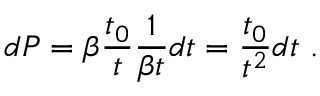Convert formula to latex. <formula><loc_0><loc_0><loc_500><loc_500>d P = \beta \frac { t _ { 0 } } { t } \frac { 1 } { \beta t } d t = \frac { t _ { 0 } } { t ^ { 2 } } d t \, .</formula> 